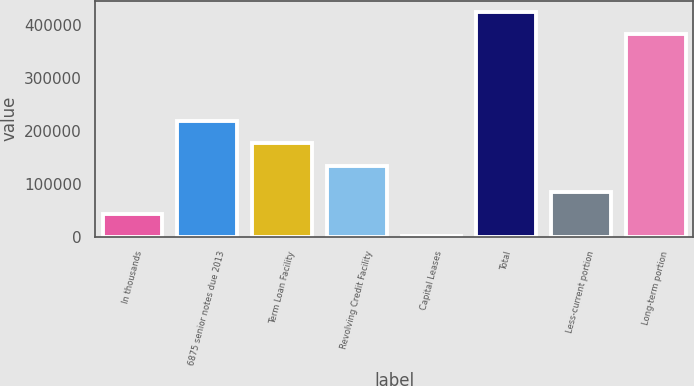Convert chart to OTSL. <chart><loc_0><loc_0><loc_500><loc_500><bar_chart><fcel>In thousands<fcel>6875 senior notes due 2013<fcel>Term Loan Facility<fcel>Revolving Credit Facility<fcel>Capital Leases<fcel>Total<fcel>Less-current portion<fcel>Long-term portion<nl><fcel>42725<fcel>218300<fcel>176150<fcel>134000<fcel>575<fcel>424157<fcel>84875<fcel>382007<nl></chart> 